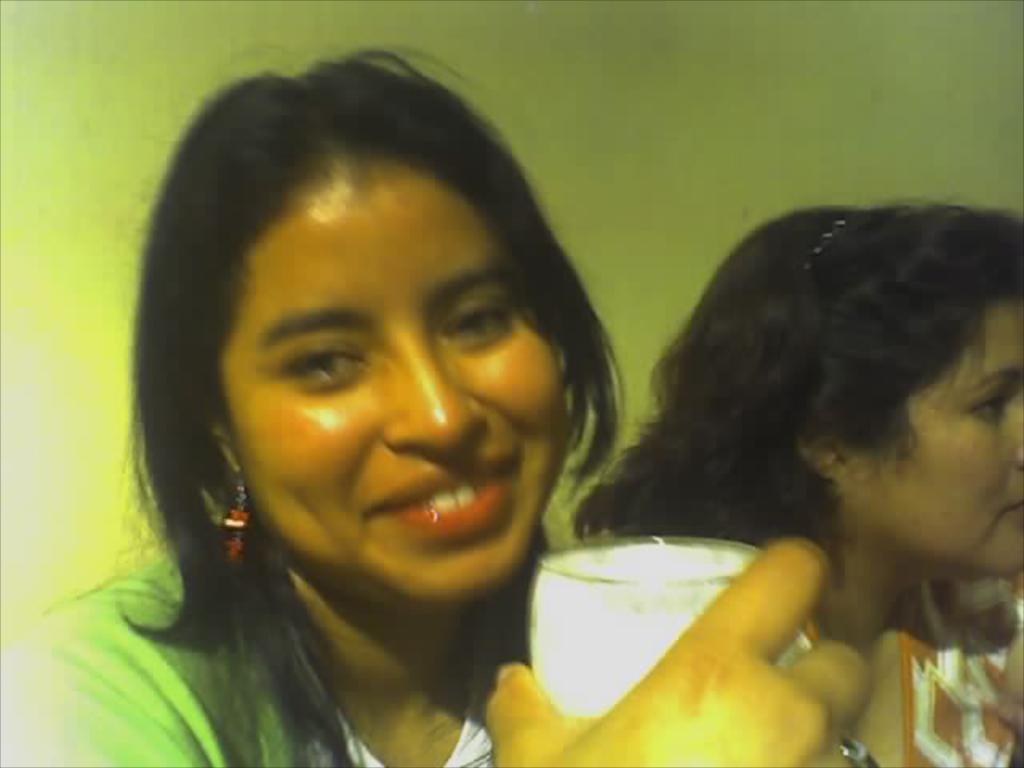Describe this image in one or two sentences. In this picture we can see two women, one woman is holding a glass and we can see a wall in the background. 